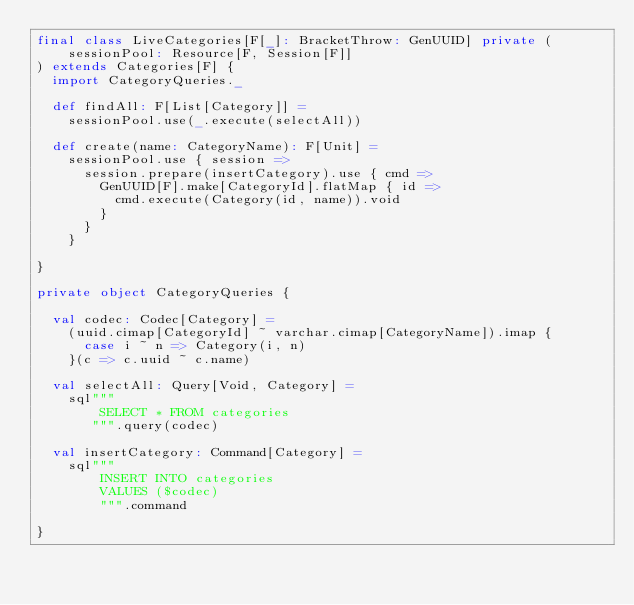<code> <loc_0><loc_0><loc_500><loc_500><_Scala_>final class LiveCategories[F[_]: BracketThrow: GenUUID] private (
    sessionPool: Resource[F, Session[F]]
) extends Categories[F] {
  import CategoryQueries._

  def findAll: F[List[Category]] =
    sessionPool.use(_.execute(selectAll))

  def create(name: CategoryName): F[Unit] =
    sessionPool.use { session =>
      session.prepare(insertCategory).use { cmd =>
        GenUUID[F].make[CategoryId].flatMap { id =>
          cmd.execute(Category(id, name)).void
        }
      }
    }

}

private object CategoryQueries {

  val codec: Codec[Category] =
    (uuid.cimap[CategoryId] ~ varchar.cimap[CategoryName]).imap {
      case i ~ n => Category(i, n)
    }(c => c.uuid ~ c.name)

  val selectAll: Query[Void, Category] =
    sql"""
        SELECT * FROM categories
       """.query(codec)

  val insertCategory: Command[Category] =
    sql"""
        INSERT INTO categories
        VALUES ($codec)
        """.command

}
</code> 